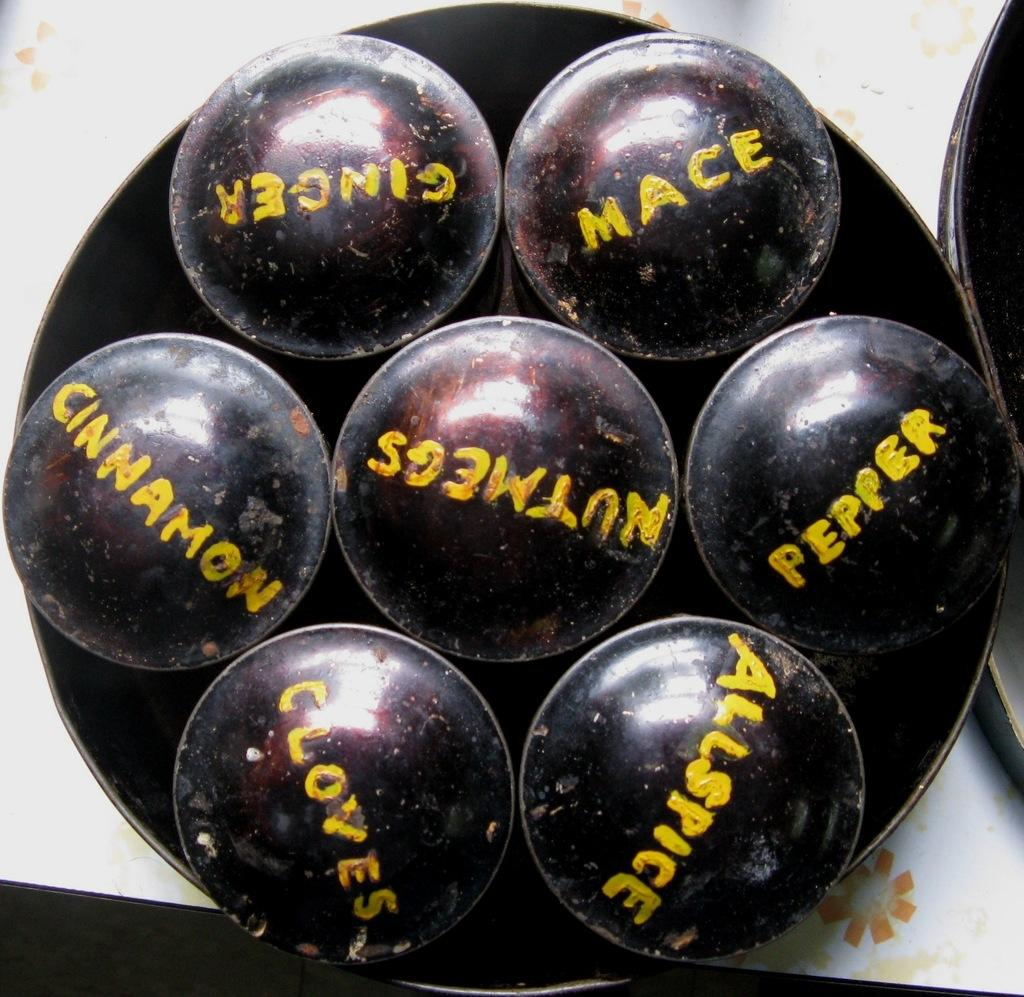What is on the plate in the image? There are objects on a plate in the image. What do the objects resemble? The objects resemble balls. Are there any markings or text on the balls? Yes, there is text on the balls. How many toes can be seen on the cloth in the image? There is no cloth or toes present in the image. 